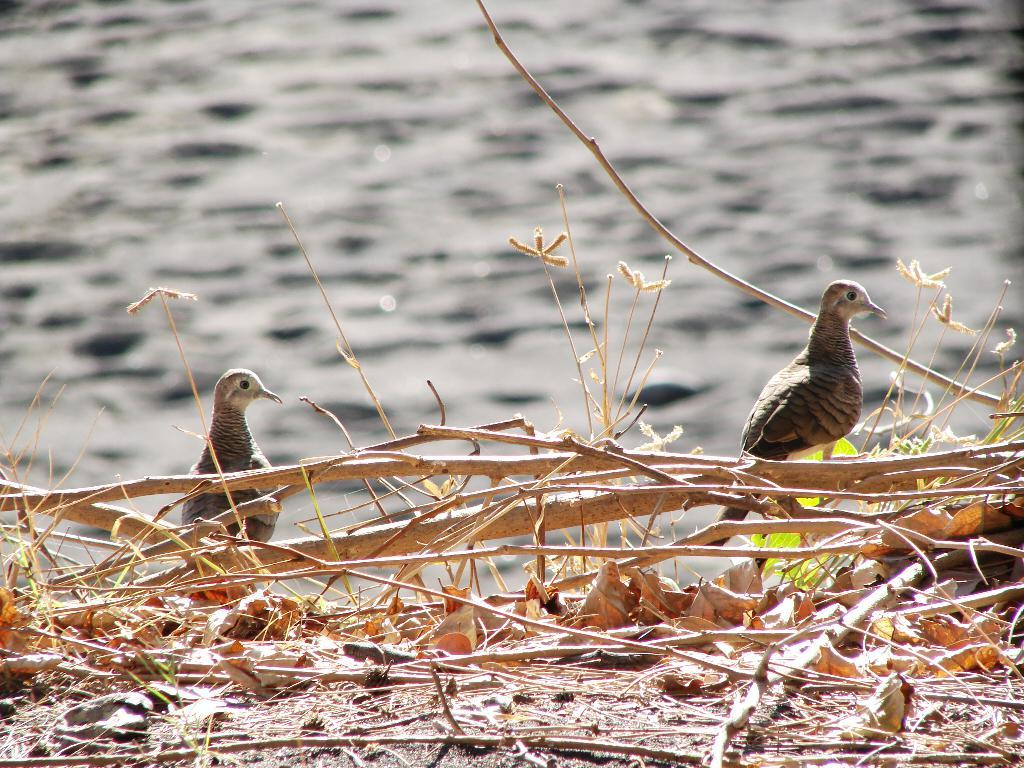What animals can be seen in the middle of the image? There are two birds in the middle of the image. What type of natural elements are present in the image? There are dried sticks, leaves, and green plants in the image. What type of man is sitting in the office in the image? There is no man or office present in the image; it features two birds and natural elements. 